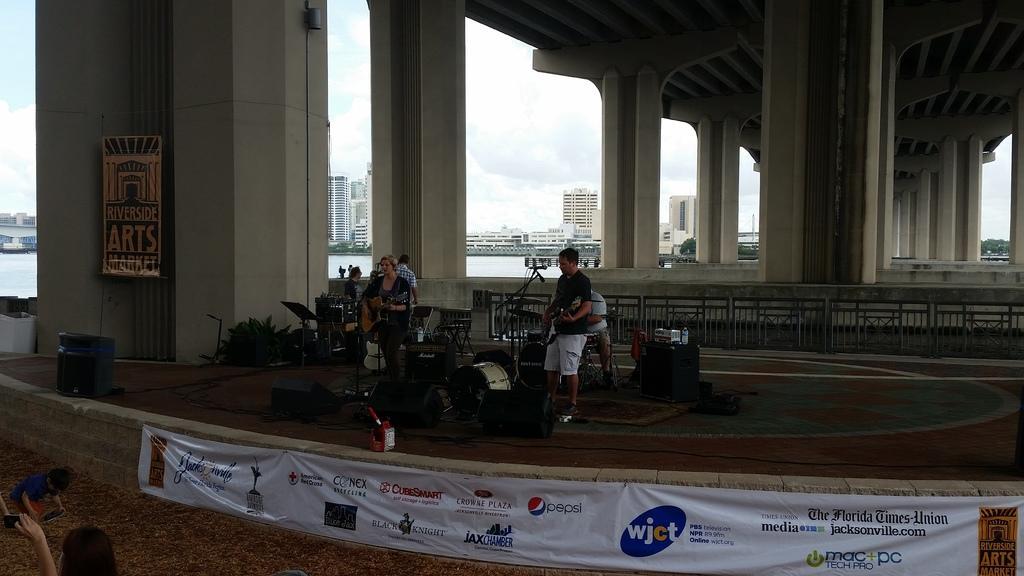Please provide a concise description of this image. In this image we can see two persons standing on stage holding guitars in their hands and group of musical instruments placed on the stage. In the background, we can see metal railing, a group of people, bridge, a group of buildings, banner with some text on it, To the left side of the image we can see a kid standing on the floor. 